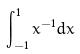Convert formula to latex. <formula><loc_0><loc_0><loc_500><loc_500>\int _ { - 1 } ^ { 1 } x ^ { - 1 } d x</formula> 